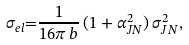Convert formula to latex. <formula><loc_0><loc_0><loc_500><loc_500>\sigma _ { e l } { = } \frac { 1 } { 1 6 \pi \, b } \, ( 1 + \alpha _ { J N } ^ { 2 } ) \, \sigma _ { J N } ^ { 2 } ,</formula> 